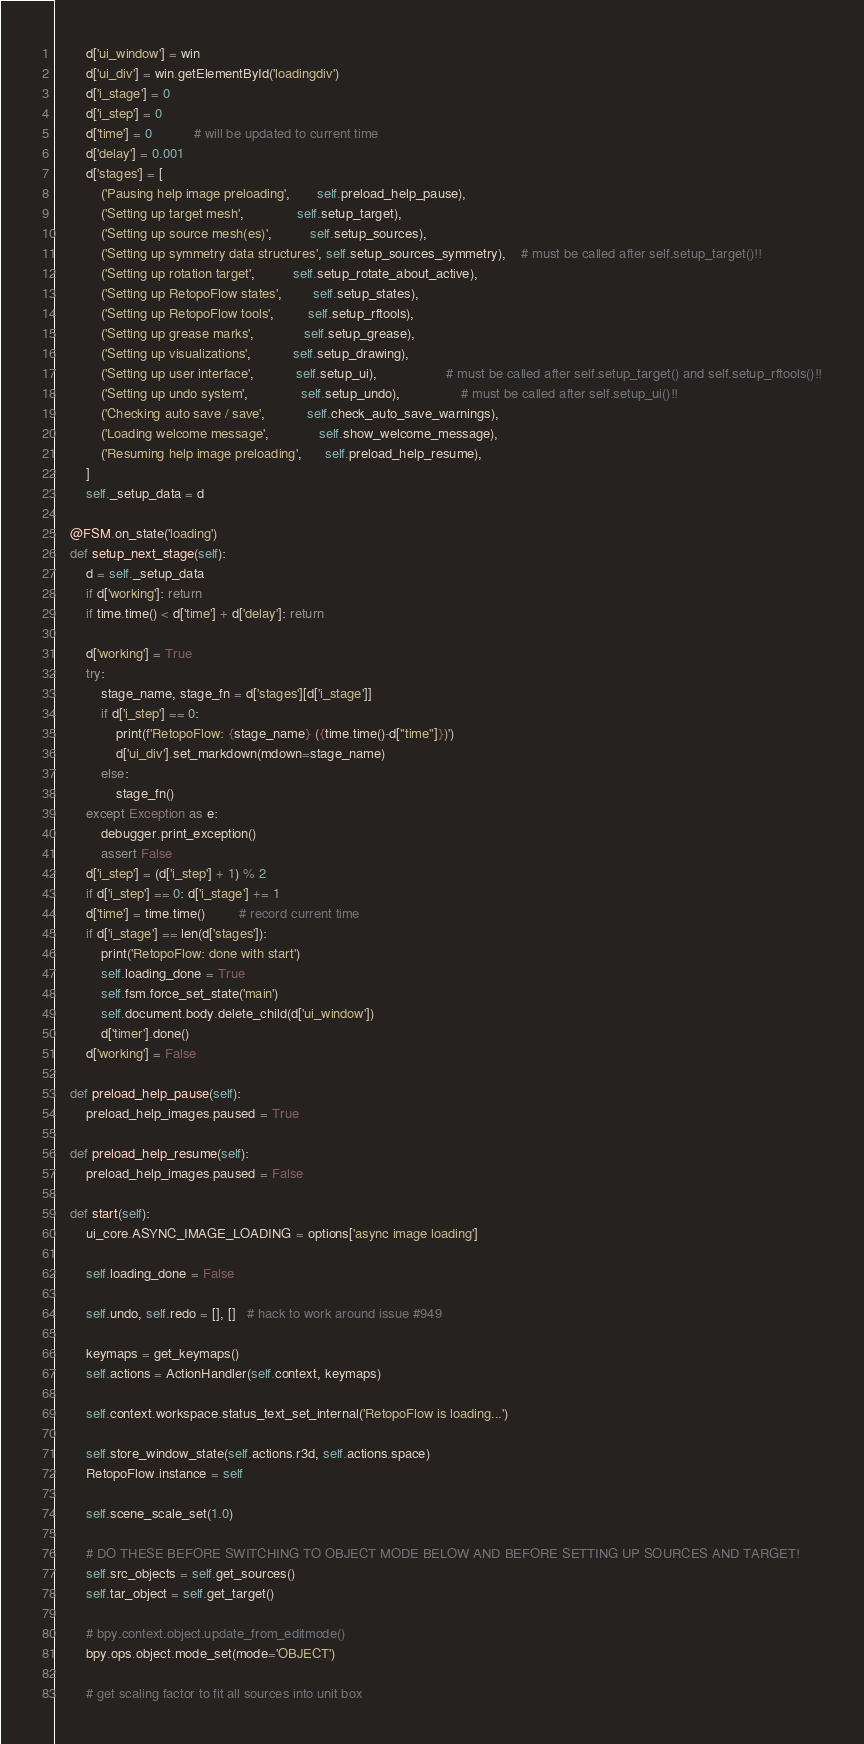<code> <loc_0><loc_0><loc_500><loc_500><_Python_>        d['ui_window'] = win
        d['ui_div'] = win.getElementById('loadingdiv')
        d['i_stage'] = 0
        d['i_step'] = 0
        d['time'] = 0           # will be updated to current time
        d['delay'] = 0.001
        d['stages'] = [
            ('Pausing help image preloading',       self.preload_help_pause),
            ('Setting up target mesh',              self.setup_target),
            ('Setting up source mesh(es)',          self.setup_sources),
            ('Setting up symmetry data structures', self.setup_sources_symmetry),    # must be called after self.setup_target()!!
            ('Setting up rotation target',          self.setup_rotate_about_active),
            ('Setting up RetopoFlow states',        self.setup_states),
            ('Setting up RetopoFlow tools',         self.setup_rftools),
            ('Setting up grease marks',             self.setup_grease),
            ('Setting up visualizations',           self.setup_drawing),
            ('Setting up user interface',           self.setup_ui),                  # must be called after self.setup_target() and self.setup_rftools()!!
            ('Setting up undo system',              self.setup_undo),                # must be called after self.setup_ui()!!
            ('Checking auto save / save',           self.check_auto_save_warnings),
            ('Loading welcome message',             self.show_welcome_message),
            ('Resuming help image preloading',      self.preload_help_resume),
        ]
        self._setup_data = d

    @FSM.on_state('loading')
    def setup_next_stage(self):
        d = self._setup_data
        if d['working']: return
        if time.time() < d['time'] + d['delay']: return

        d['working'] = True
        try:
            stage_name, stage_fn = d['stages'][d['i_stage']]
            if d['i_step'] == 0:
                print(f'RetopoFlow: {stage_name} ({time.time()-d["time"]})')
                d['ui_div'].set_markdown(mdown=stage_name)
            else:
                stage_fn()
        except Exception as e:
            debugger.print_exception()
            assert False
        d['i_step'] = (d['i_step'] + 1) % 2
        if d['i_step'] == 0: d['i_stage'] += 1
        d['time'] = time.time()         # record current time
        if d['i_stage'] == len(d['stages']):
            print('RetopoFlow: done with start')
            self.loading_done = True
            self.fsm.force_set_state('main')
            self.document.body.delete_child(d['ui_window'])
            d['timer'].done()
        d['working'] = False

    def preload_help_pause(self):
        preload_help_images.paused = True

    def preload_help_resume(self):
        preload_help_images.paused = False

    def start(self):
        ui_core.ASYNC_IMAGE_LOADING = options['async image loading']

        self.loading_done = False

        self.undo, self.redo = [], []   # hack to work around issue #949

        keymaps = get_keymaps()
        self.actions = ActionHandler(self.context, keymaps)

        self.context.workspace.status_text_set_internal('RetopoFlow is loading...')

        self.store_window_state(self.actions.r3d, self.actions.space)
        RetopoFlow.instance = self

        self.scene_scale_set(1.0)

        # DO THESE BEFORE SWITCHING TO OBJECT MODE BELOW AND BEFORE SETTING UP SOURCES AND TARGET!
        self.src_objects = self.get_sources()
        self.tar_object = self.get_target()

        # bpy.context.object.update_from_editmode()
        bpy.ops.object.mode_set(mode='OBJECT')

        # get scaling factor to fit all sources into unit box</code> 